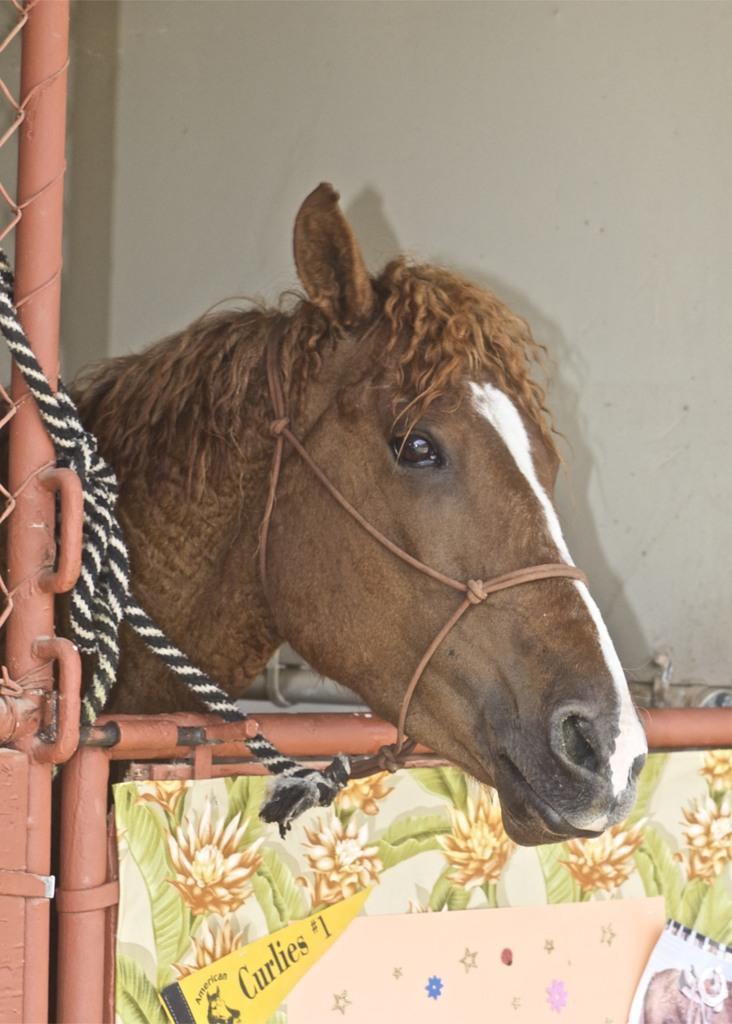Please provide a concise description of this image. In this picture, we can see a horse, pole, fence, rope, the gate, poster with some text, images, and we can see the wall. 